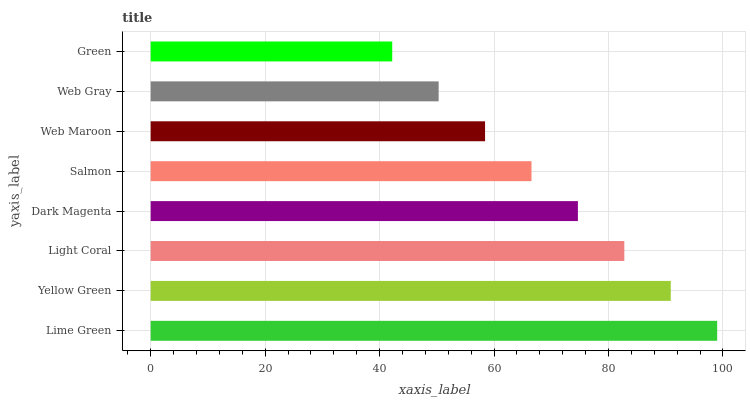Is Green the minimum?
Answer yes or no. Yes. Is Lime Green the maximum?
Answer yes or no. Yes. Is Yellow Green the minimum?
Answer yes or no. No. Is Yellow Green the maximum?
Answer yes or no. No. Is Lime Green greater than Yellow Green?
Answer yes or no. Yes. Is Yellow Green less than Lime Green?
Answer yes or no. Yes. Is Yellow Green greater than Lime Green?
Answer yes or no. No. Is Lime Green less than Yellow Green?
Answer yes or no. No. Is Dark Magenta the high median?
Answer yes or no. Yes. Is Salmon the low median?
Answer yes or no. Yes. Is Yellow Green the high median?
Answer yes or no. No. Is Web Gray the low median?
Answer yes or no. No. 